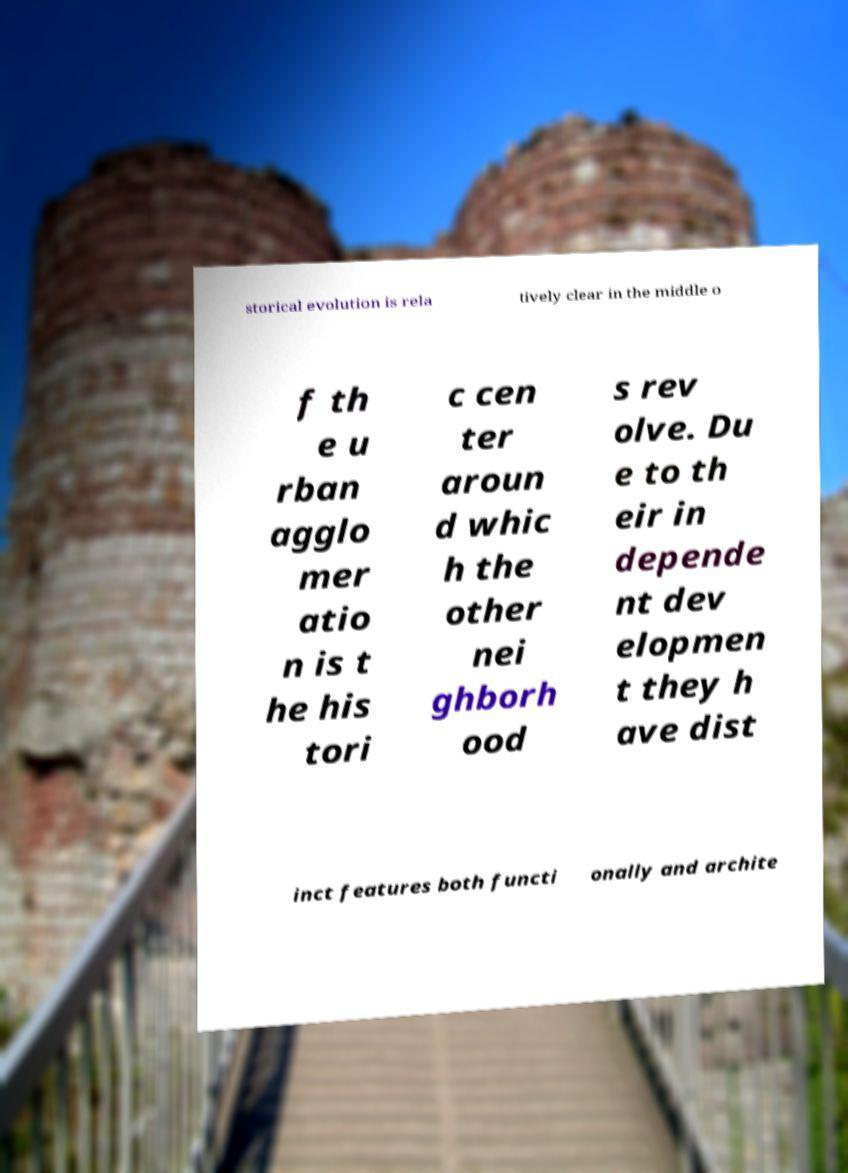What messages or text are displayed in this image? I need them in a readable, typed format. storical evolution is rela tively clear in the middle o f th e u rban agglo mer atio n is t he his tori c cen ter aroun d whic h the other nei ghborh ood s rev olve. Du e to th eir in depende nt dev elopmen t they h ave dist inct features both functi onally and archite 